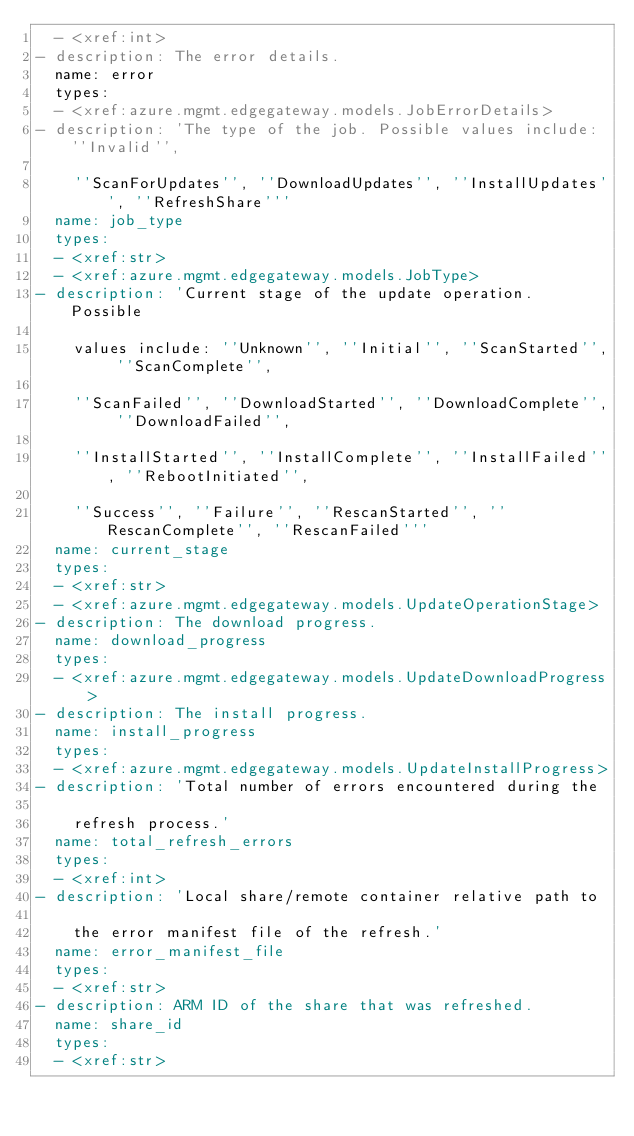<code> <loc_0><loc_0><loc_500><loc_500><_YAML_>  - <xref:int>
- description: The error details.
  name: error
  types:
  - <xref:azure.mgmt.edgegateway.models.JobErrorDetails>
- description: 'The type of the job. Possible values include: ''Invalid'',

    ''ScanForUpdates'', ''DownloadUpdates'', ''InstallUpdates'', ''RefreshShare'''
  name: job_type
  types:
  - <xref:str>
  - <xref:azure.mgmt.edgegateway.models.JobType>
- description: 'Current stage of the update operation. Possible

    values include: ''Unknown'', ''Initial'', ''ScanStarted'', ''ScanComplete'',

    ''ScanFailed'', ''DownloadStarted'', ''DownloadComplete'', ''DownloadFailed'',

    ''InstallStarted'', ''InstallComplete'', ''InstallFailed'', ''RebootInitiated'',

    ''Success'', ''Failure'', ''RescanStarted'', ''RescanComplete'', ''RescanFailed'''
  name: current_stage
  types:
  - <xref:str>
  - <xref:azure.mgmt.edgegateway.models.UpdateOperationStage>
- description: The download progress.
  name: download_progress
  types:
  - <xref:azure.mgmt.edgegateway.models.UpdateDownloadProgress>
- description: The install progress.
  name: install_progress
  types:
  - <xref:azure.mgmt.edgegateway.models.UpdateInstallProgress>
- description: 'Total number of errors encountered during the

    refresh process.'
  name: total_refresh_errors
  types:
  - <xref:int>
- description: 'Local share/remote container relative path to

    the error manifest file of the refresh.'
  name: error_manifest_file
  types:
  - <xref:str>
- description: ARM ID of the share that was refreshed.
  name: share_id
  types:
  - <xref:str>
</code> 